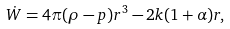<formula> <loc_0><loc_0><loc_500><loc_500>\dot { W } = 4 \pi ( \rho - p ) r ^ { 3 } - 2 k ( 1 + \alpha ) r ,</formula> 